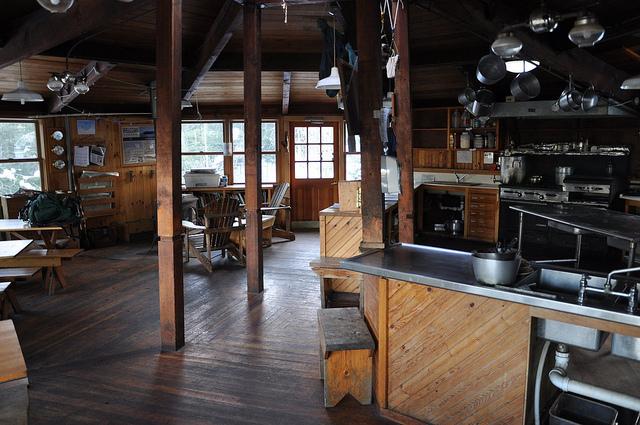In what environment would you most likely find a house like this?
Short answer required. Forest. What kind of flooring is this?
Keep it brief. Wood. Are there any people in the room?
Short answer required. No. 